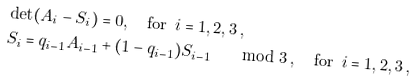Convert formula to latex. <formula><loc_0><loc_0><loc_500><loc_500>& \det ( A _ { i } - S _ { i } ) = 0 , \quad \text {for } \, i = 1 , 2 , 3 \, , \\ & S _ { i } = q _ { i - 1 } A _ { i - 1 } + ( 1 - q _ { i - 1 } ) S _ { i - 1 } \quad \mod 3 \, , \quad \text {for } \, i = 1 , 2 , 3 \, ,</formula> 